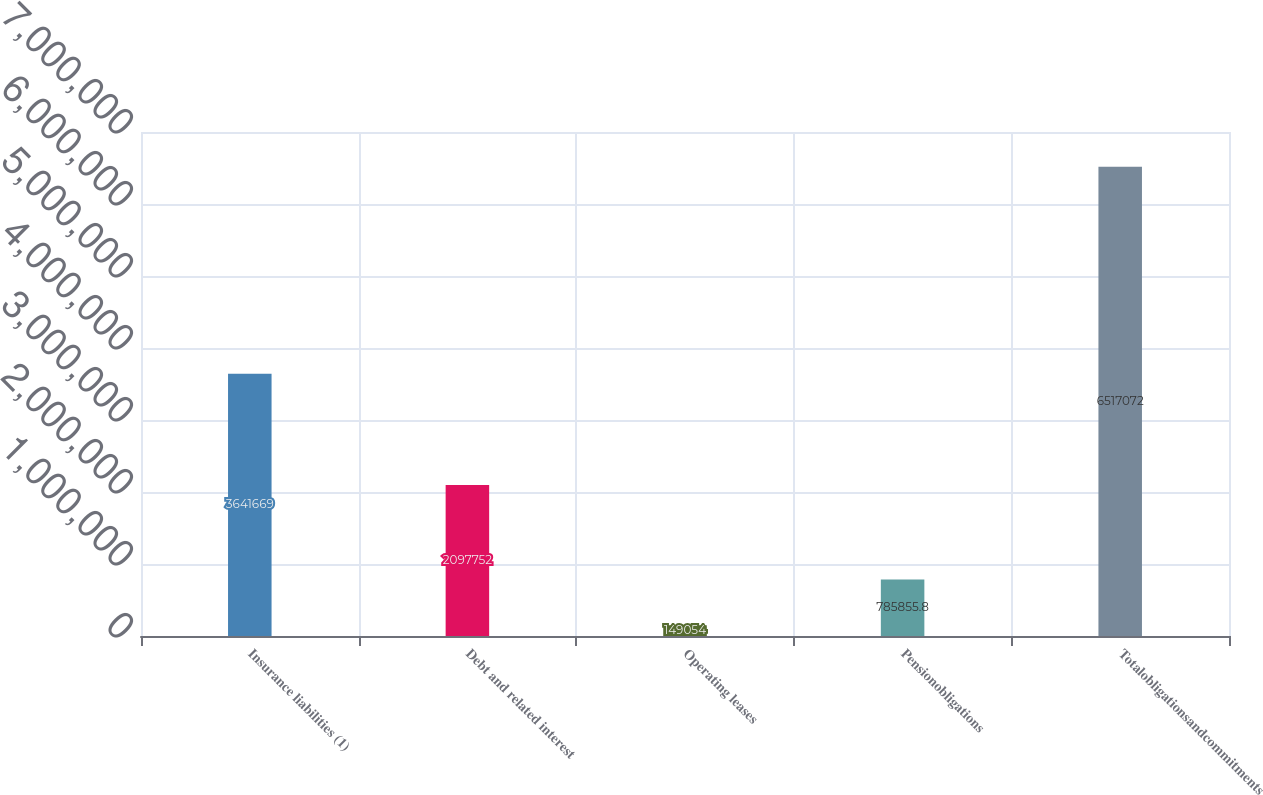<chart> <loc_0><loc_0><loc_500><loc_500><bar_chart><fcel>Insurance liabilities (1)<fcel>Debt and related interest<fcel>Operating leases<fcel>Pensionobligations<fcel>Totalobligationsandcommitments<nl><fcel>3.64167e+06<fcel>2.09775e+06<fcel>149054<fcel>785856<fcel>6.51707e+06<nl></chart> 